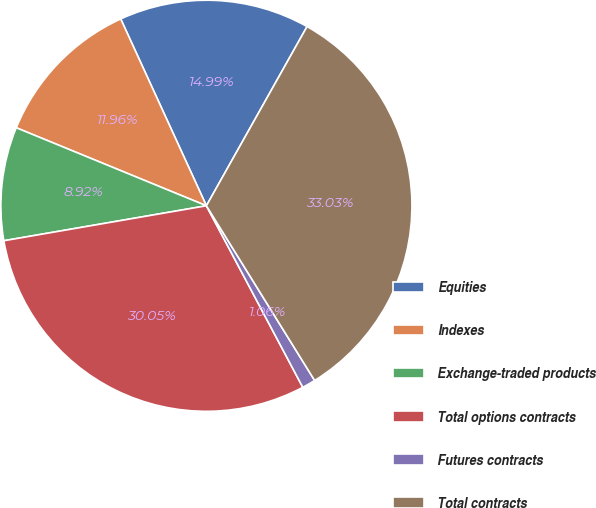Convert chart. <chart><loc_0><loc_0><loc_500><loc_500><pie_chart><fcel>Equities<fcel>Indexes<fcel>Exchange-traded products<fcel>Total options contracts<fcel>Futures contracts<fcel>Total contracts<nl><fcel>14.99%<fcel>11.96%<fcel>8.92%<fcel>30.05%<fcel>1.06%<fcel>33.03%<nl></chart> 